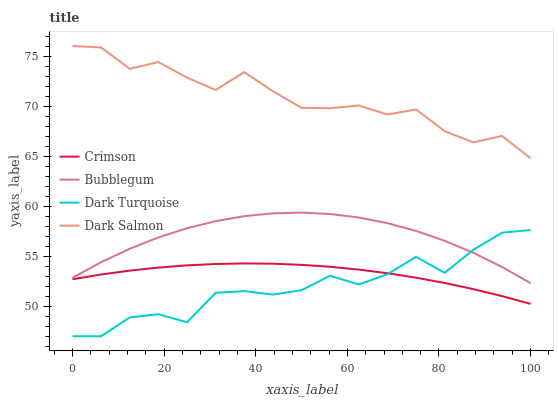Does Dark Turquoise have the minimum area under the curve?
Answer yes or no. Yes. Does Dark Salmon have the maximum area under the curve?
Answer yes or no. Yes. Does Dark Salmon have the minimum area under the curve?
Answer yes or no. No. Does Dark Turquoise have the maximum area under the curve?
Answer yes or no. No. Is Crimson the smoothest?
Answer yes or no. Yes. Is Dark Turquoise the roughest?
Answer yes or no. Yes. Is Dark Salmon the smoothest?
Answer yes or no. No. Is Dark Salmon the roughest?
Answer yes or no. No. Does Dark Turquoise have the lowest value?
Answer yes or no. Yes. Does Dark Salmon have the lowest value?
Answer yes or no. No. Does Dark Salmon have the highest value?
Answer yes or no. Yes. Does Dark Turquoise have the highest value?
Answer yes or no. No. Is Dark Turquoise less than Dark Salmon?
Answer yes or no. Yes. Is Dark Salmon greater than Dark Turquoise?
Answer yes or no. Yes. Does Crimson intersect Dark Turquoise?
Answer yes or no. Yes. Is Crimson less than Dark Turquoise?
Answer yes or no. No. Is Crimson greater than Dark Turquoise?
Answer yes or no. No. Does Dark Turquoise intersect Dark Salmon?
Answer yes or no. No. 